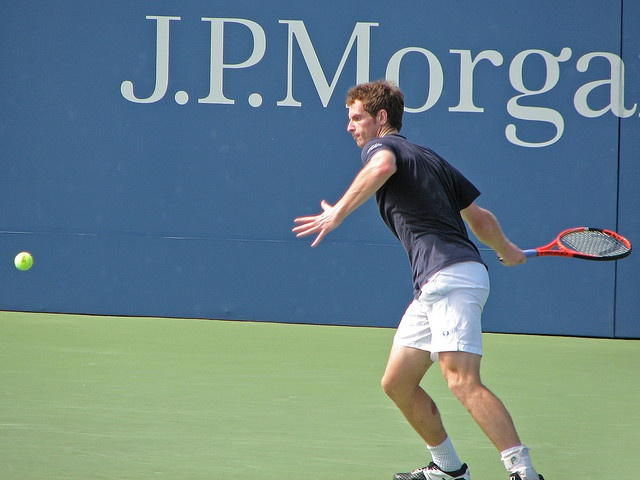Describe the objects in this image and their specific colors. I can see people in blue, black, darkgray, white, and gray tones, tennis racket in blue, darkgray, and gray tones, and sports ball in blue, ivory, lightgreen, and khaki tones in this image. 